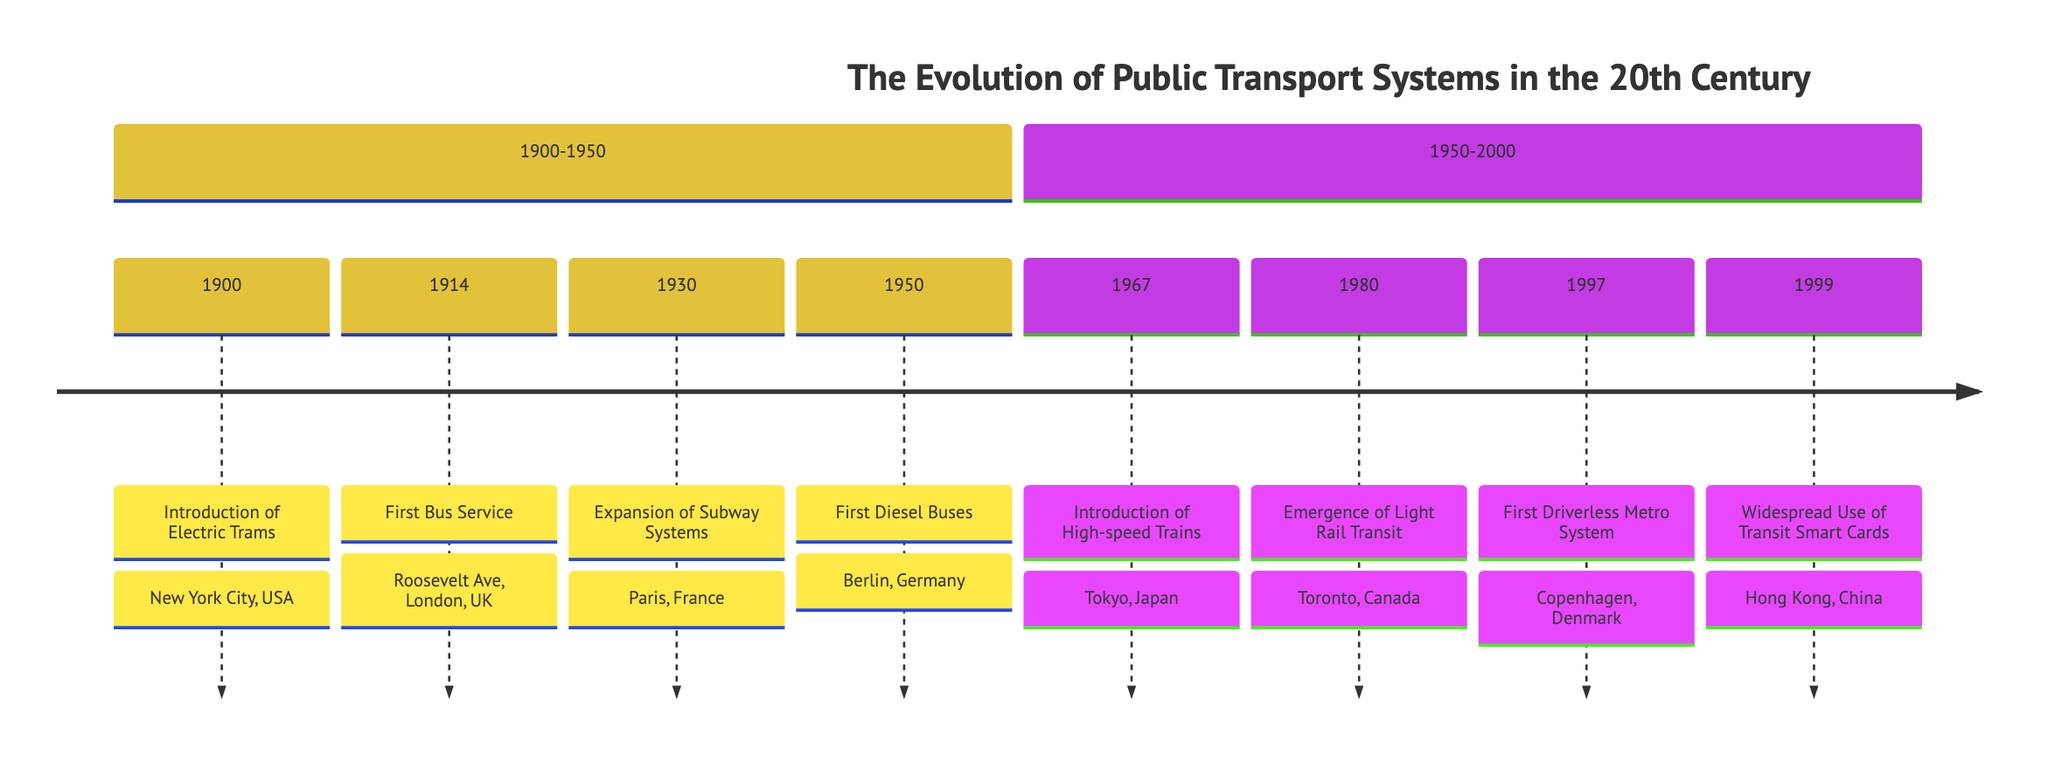What year did the introduction of electric trams occur? The diagram shows "1900 : Introduction of Electric Trams" in the section "1900-1950". This directly indicates the year as 1900.
Answer: 1900 Which city saw the first bus service introduced? The timeline entry "1914 : First Bus Service : Roosevelt Ave, London, UK" clearly states that London, UK was the location for the first bus service introduced.
Answer: London How many significant public transport developments are listed between 1900 and 1950? Counting the individual entries from "1900" to "1950", there are four events (1900, 1914, 1930, and 1950).
Answer: 4 What was the last public transport development listed in the diagram? The timeline shows "1999 : Widespread Use of Transit Smart Cards : Hong Kong, China" as the last event recorded in the timeline.
Answer: Widespread Use of Transit Smart Cards Which system was introduced in Tokyo, Japan in 1967? The timeline entry reads "1967 : Introduction of High-speed Trains : Tokyo, Japan", directly answering that the system introduced was high-speed trains.
Answer: High-speed Trains What was the first driverless metro system and where was it introduced? The diagram states "1997 : First Driverless Metro System : Copenhagen, Denmark", providing both the system name and location.
Answer: First Driverless Metro System, Copenhagen In which section was the emergence of light rail transit mentioned? The emergence of light rail transit is noted under "1980 : Emergence of Light Rail Transit : Toronto, Canada" in the "1950-2000" section of the diagram.
Answer: 1950-2000 How many developments occurred in the second half of the 20th century (1950-2000)? The entries "1967", "1980", "1997", and "1999" indicate four developments listed in the "1950-2000" section, leading to the answer.
Answer: 4 What is the common theme in the years listed from 1900 to 1950? Every significant transport development listed within this range involves innovations that improved public transport, specifically introducing or expanding systems like trams and subways. The common theme can be summarized as the introduction of electric and diesel systems.
Answer: Introduction of electric and diesel systems 